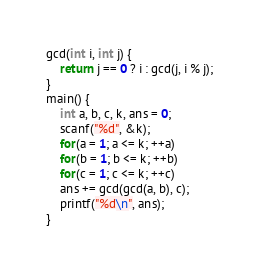<code> <loc_0><loc_0><loc_500><loc_500><_C_>gcd(int i, int j) {
    return j == 0 ? i : gcd(j, i % j);
}
main() {
    int a, b, c, k, ans = 0;
    scanf("%d", &k);
    for(a = 1; a <= k; ++a)
    for(b = 1; b <= k; ++b)
    for(c = 1; c <= k; ++c) 
    ans += gcd(gcd(a, b), c);
    printf("%d\n", ans);
}
</code> 